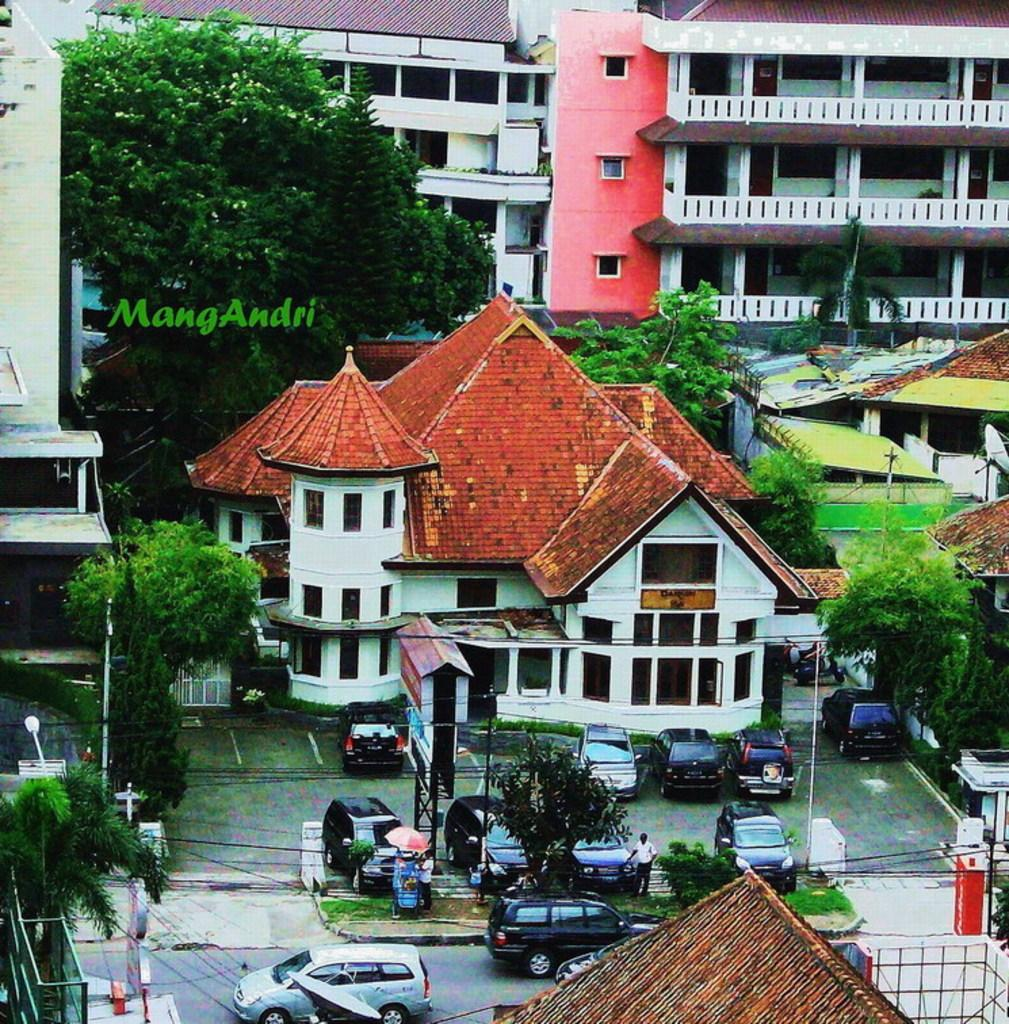What type of vehicles can be seen in the image? There are cars in the image. What type of vegetation is present in the image? There is grass, plants, and trees in the image. What type of structures can be seen in the image? There are poles, boards, houses, and buildings in the image. What type of surface is visible in the image? There is a road in the image. Are there any living beings present in the image? Yes, there are people in the image. Can you tell me how many clover leaves are visible in the image? There is no clover present in the image, so it is not possible to determine the number of leaves. What type of behavior can be observed in the people in the image? The provided facts do not give any information about the behavior of the people in the image. Is there any lettuce visible in the image? There is no lettuce present in the image. 